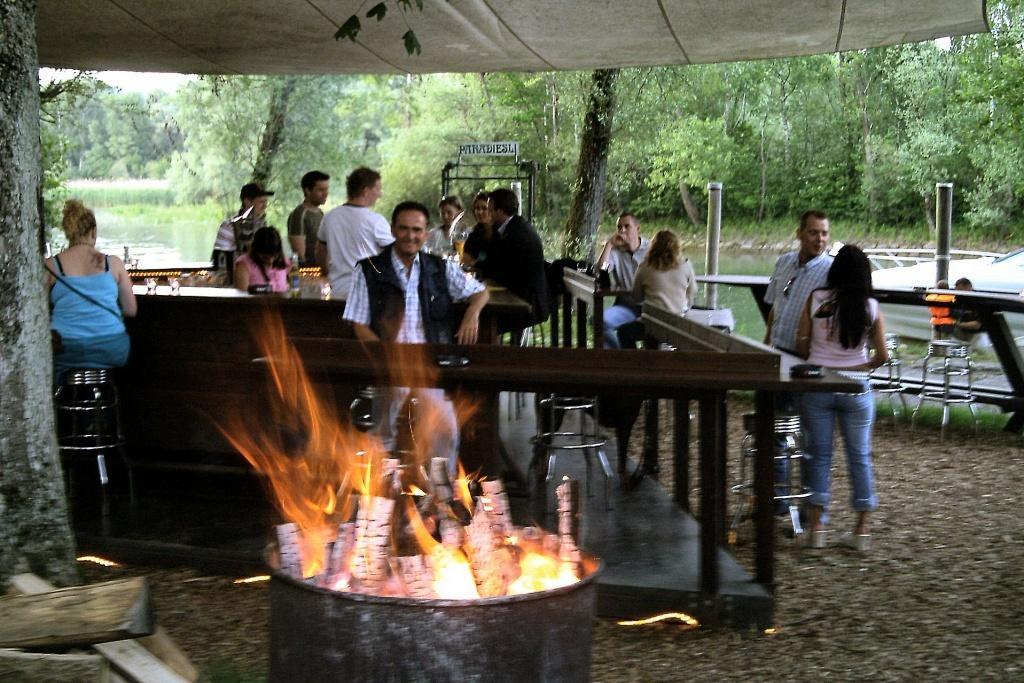Please provide a concise description of this image. At the bottom of the image there is fire. Behind the fire there is railing. Behind the railing there are few people sitting on the stools and there are few people standing. In between them there is a table with few items on it. On the right side of the image there are few people sitting and few people standing. Behind the railing there are poles and also there is a boat on the water. In the background there are trees. 